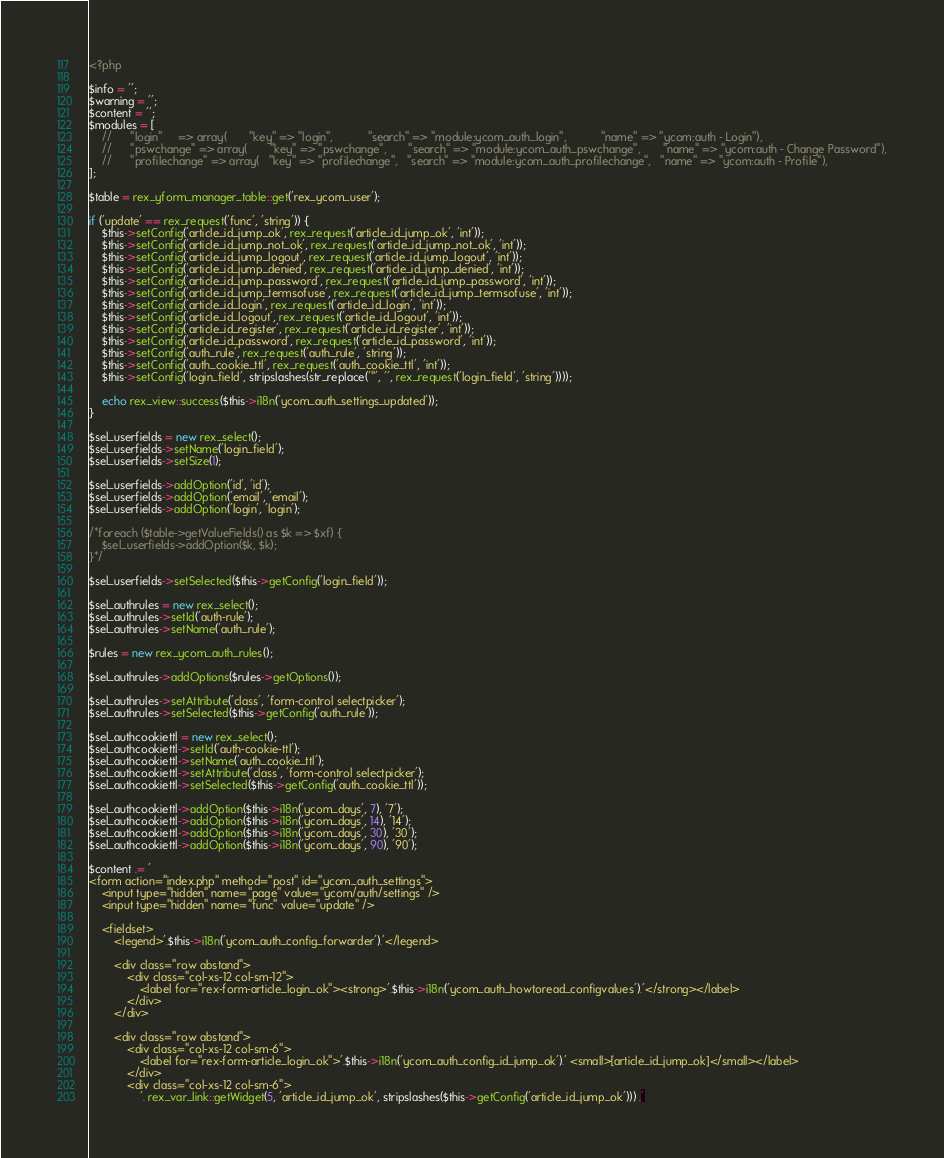<code> <loc_0><loc_0><loc_500><loc_500><_PHP_><?php

$info = '';
$warning = '';
$content = '';
$modules = [
    //		"login"		=> array(		"key" => "login", 			"search" => "module:ycom_auth_login",			"name" => "ycom:auth - Login"),
    // 		"pswchange"	=> array(		"key" => "pswchange", 		"search" => "module:ycom_auth_pswchange",		"name" => "ycom:auth - Change Password"),
    // 		"profilechange"	=> array(	"key" => "profilechange", 	"search" => "module:ycom_auth_profilechange",	"name" => "ycom:auth - Profile"),
];

$table = rex_yform_manager_table::get('rex_ycom_user');

if ('update' == rex_request('func', 'string')) {
    $this->setConfig('article_id_jump_ok', rex_request('article_id_jump_ok', 'int'));
    $this->setConfig('article_id_jump_not_ok', rex_request('article_id_jump_not_ok', 'int'));
    $this->setConfig('article_id_jump_logout', rex_request('article_id_jump_logout', 'int'));
    $this->setConfig('article_id_jump_denied', rex_request('article_id_jump_denied', 'int'));
    $this->setConfig('article_id_jump_password', rex_request('article_id_jump_password', 'int'));
    $this->setConfig('article_id_jump_termsofuse', rex_request('article_id_jump_termsofuse', 'int'));
    $this->setConfig('article_id_login', rex_request('article_id_login', 'int'));
    $this->setConfig('article_id_logout', rex_request('article_id_logout', 'int'));
    $this->setConfig('article_id_register', rex_request('article_id_register', 'int'));
    $this->setConfig('article_id_password', rex_request('article_id_password', 'int'));
    $this->setConfig('auth_rule', rex_request('auth_rule', 'string'));
    $this->setConfig('auth_cookie_ttl', rex_request('auth_cookie_ttl', 'int'));
    $this->setConfig('login_field', stripslashes(str_replace('"', '', rex_request('login_field', 'string'))));

    echo rex_view::success($this->i18n('ycom_auth_settings_updated'));
}

$sel_userfields = new rex_select();
$sel_userfields->setName('login_field');
$sel_userfields->setSize(1);

$sel_userfields->addOption('id', 'id');
$sel_userfields->addOption('email', 'email');
$sel_userfields->addOption('login', 'login');

/*foreach ($table->getValueFields() as $k => $xf) {
    $sel_userfields->addOption($k, $k);
}*/

$sel_userfields->setSelected($this->getConfig('login_field'));

$sel_authrules = new rex_select();
$sel_authrules->setId('auth-rule');
$sel_authrules->setName('auth_rule');

$rules = new rex_ycom_auth_rules();

$sel_authrules->addOptions($rules->getOptions());

$sel_authrules->setAttribute('class', 'form-control selectpicker');
$sel_authrules->setSelected($this->getConfig('auth_rule'));

$sel_authcookiettl = new rex_select();
$sel_authcookiettl->setId('auth-cookie-ttl');
$sel_authcookiettl->setName('auth_cookie_ttl');
$sel_authcookiettl->setAttribute('class', 'form-control selectpicker');
$sel_authcookiettl->setSelected($this->getConfig('auth_cookie_ttl'));

$sel_authcookiettl->addOption($this->i18n('ycom_days', 7), '7');
$sel_authcookiettl->addOption($this->i18n('ycom_days', 14), '14');
$sel_authcookiettl->addOption($this->i18n('ycom_days', 30), '30');
$sel_authcookiettl->addOption($this->i18n('ycom_days', 90), '90');

$content .= '
<form action="index.php" method="post" id="ycom_auth_settings">
    <input type="hidden" name="page" value="ycom/auth/settings" />
    <input type="hidden" name="func" value="update" />

	<fieldset>
		<legend>'.$this->i18n('ycom_auth_config_forwarder').'</legend>

        <div class="row abstand">
			<div class="col-xs-12 col-sm-12">
				<label for="rex-form-article_login_ok"><strong>'.$this->i18n('ycom_auth_howtoread_configvalues').'</strong></label>
			</div>
		</div>

		<div class="row abstand">
			<div class="col-xs-12 col-sm-6">
				<label for="rex-form-article_login_ok">'.$this->i18n('ycom_auth_config_id_jump_ok').' <small>[article_id_jump_ok]</small></label>
			</div>
			<div class="col-xs-12 col-sm-6">
				'. rex_var_link::getWidget(5, 'article_id_jump_ok', stripslashes($this->getConfig('article_id_jump_ok'))) .'</code> 